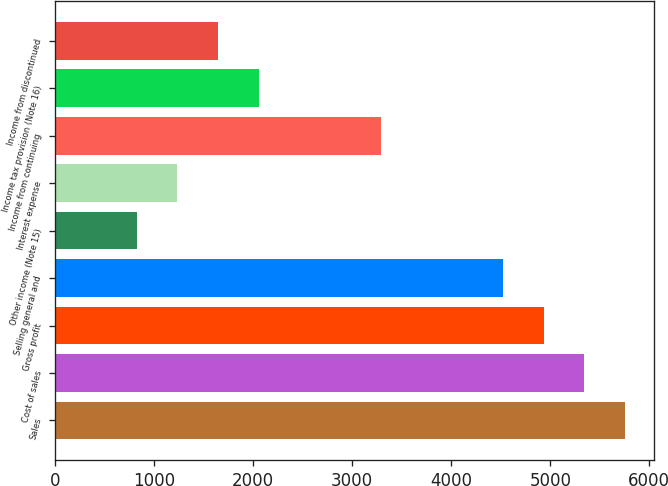Convert chart to OTSL. <chart><loc_0><loc_0><loc_500><loc_500><bar_chart><fcel>Sales<fcel>Cost of sales<fcel>Gross profit<fcel>Selling general and<fcel>Other income (Note 15)<fcel>Interest expense<fcel>Income from continuing<fcel>Income tax provision (Note 16)<fcel>Income from discontinued<nl><fcel>5755.9<fcel>5344.8<fcel>4933.7<fcel>4522.6<fcel>822.7<fcel>1233.8<fcel>3289.3<fcel>2056<fcel>1644.9<nl></chart> 